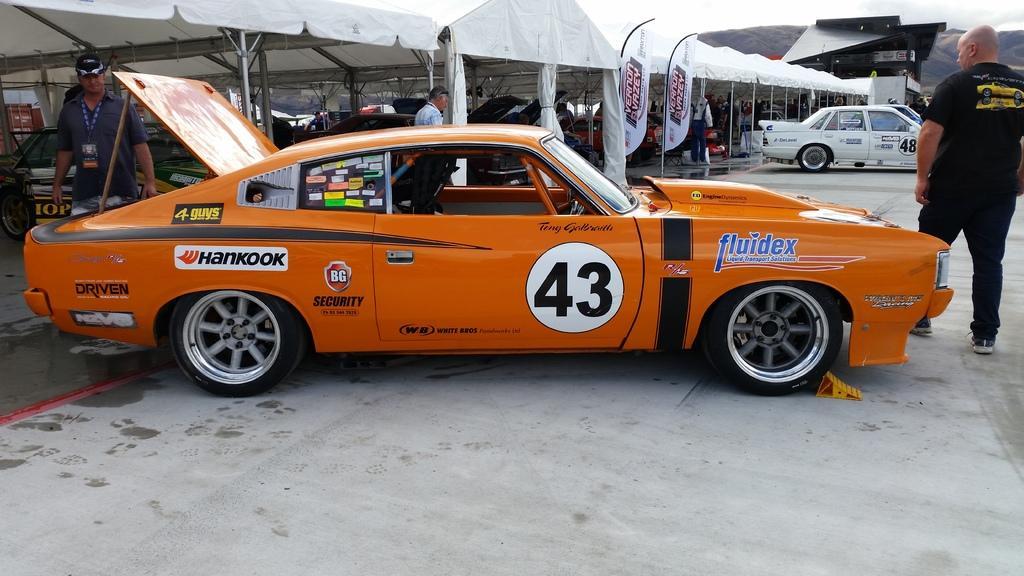Please provide a concise description of this image. In this image we can see a car. Also there are few people. In the back there are cars. Also there are tents with poles and there are banners. 